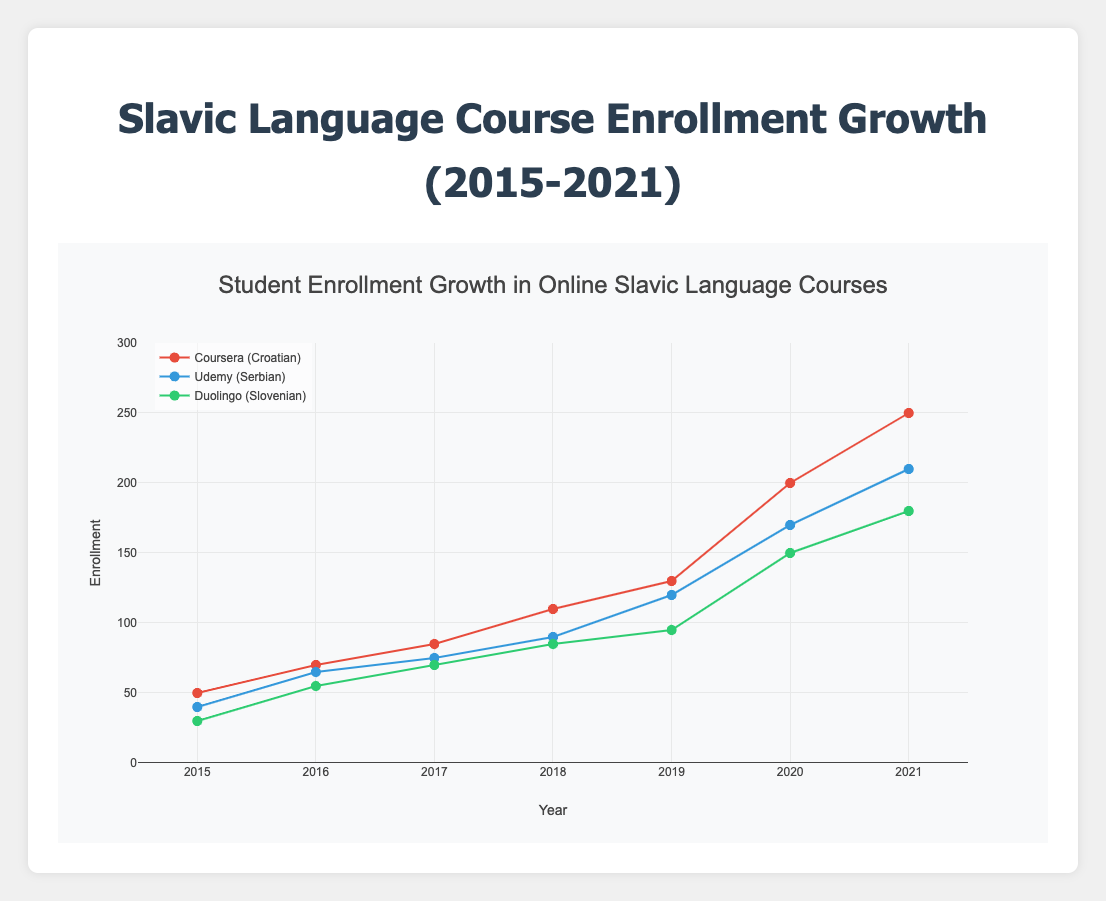What is the title of the plot? The title of the plot is written at the top and indicates the main subject of the figure. The title is "Student Enrollment Growth in Online Slavic Language Courses."
Answer: Student Enrollment Growth in Online Slavic Language Courses What is the enrollment figure for Croatian courses on Coursera in 2017? By looking at the plot for the particular year 2017 and the specific trace for Coursera's Croatian courses, the enrollment can be identified. For 2017, it is 85.
Answer: 85 How does enrollment for Serbian courses on Udemy in 2019 compare to that in 2020? The trace for Serbian courses on Udemy shows the points for 2019 and 2020. Enrollment was 120 in 2019 and increased to 170 in 2020. Hence, enrollment increased by 50.
Answer: It increased by 50 Which platform had the lowest enrollment for the Slovenian language course in 2015? In 2015, Slovenian courses are only provided on Duolingo. Therefore, the enrollment on Duolingo in 2015 is also the lowest figure for that year, which is 30.
Answer: Duolingo with 30 enrollments Calculate the average enrollment for Croatian language courses on Coursera from 2015 to 2021. By finding and adding the enrollments for each year (50, 70, 85, 110, 130, 200, 250) and then dividing by the number of years (7), the average enrollment can be calculated. The sum is 895, so the average is 895/7.
Answer: 127.86 Which year saw the highest enrollment for the Slovenian language course on Duolingo? By comparing the points on the Duolingo trace for Slovenian, the highest enrollment occurs in 2021 with a count of 180.
Answer: 2021 Has the enrollment in Croatian courses on Coursera increased or decreased from 2015 to 2021? Observing the trend line for Coursera's Croatian courses from 2015 to 2021, the enrollment continuously increases from 50 to 250.
Answer: Increased What is the difference in enrollment between the Serbian course on Udemy and the Croatian course on Coursera in 2021? By identifying the enrollment points for both courses in 2021, which are 250 for Croatian on Coursera and 210 for Serbian on Udemy, the difference is 250 - 210.
Answer: 40 Which platform shows a consistent increase in student enrollments from 2015 to 2021 for Slovenian language courses? Looking at the trace for Duolingo with the Slovenian language, it is clear that enrollment increases each year consistently from 2015 to 2021.
Answer: Duolingo What was the enrollment growth rate for the Serbian language course on Udemy between 2015 and 2021? To find the growth rate, first find the enrollment in 2015 (40) and 2021 (210). Then use the formula (final value - initial value) / initial value * 100. The growth rate is (210 - 40) / 40 * 100.
Answer: 425% 